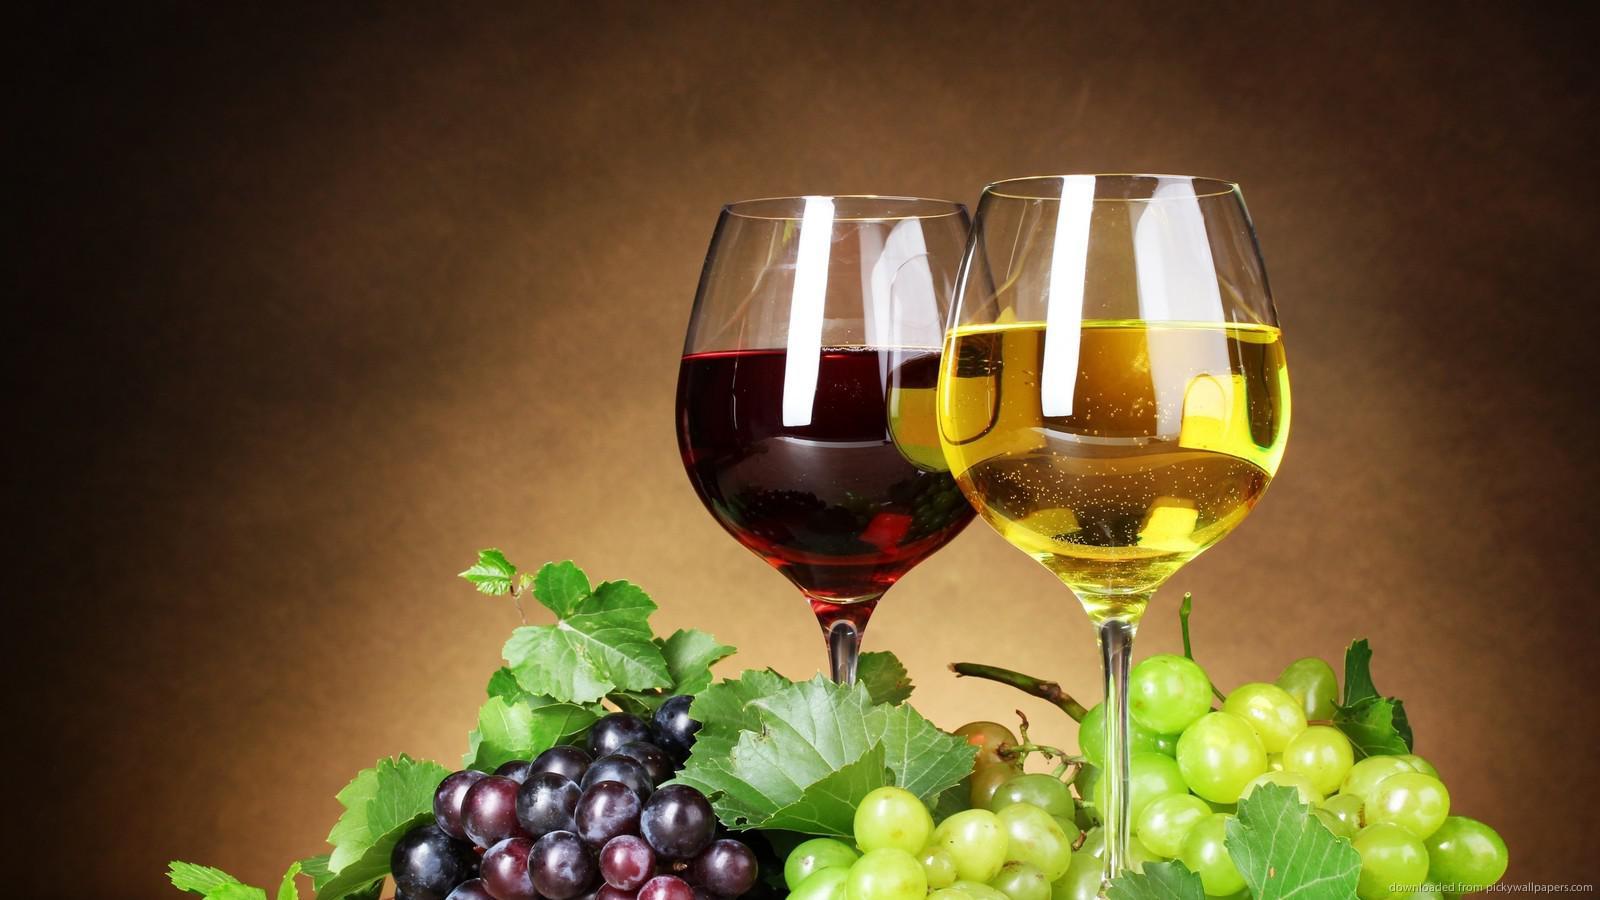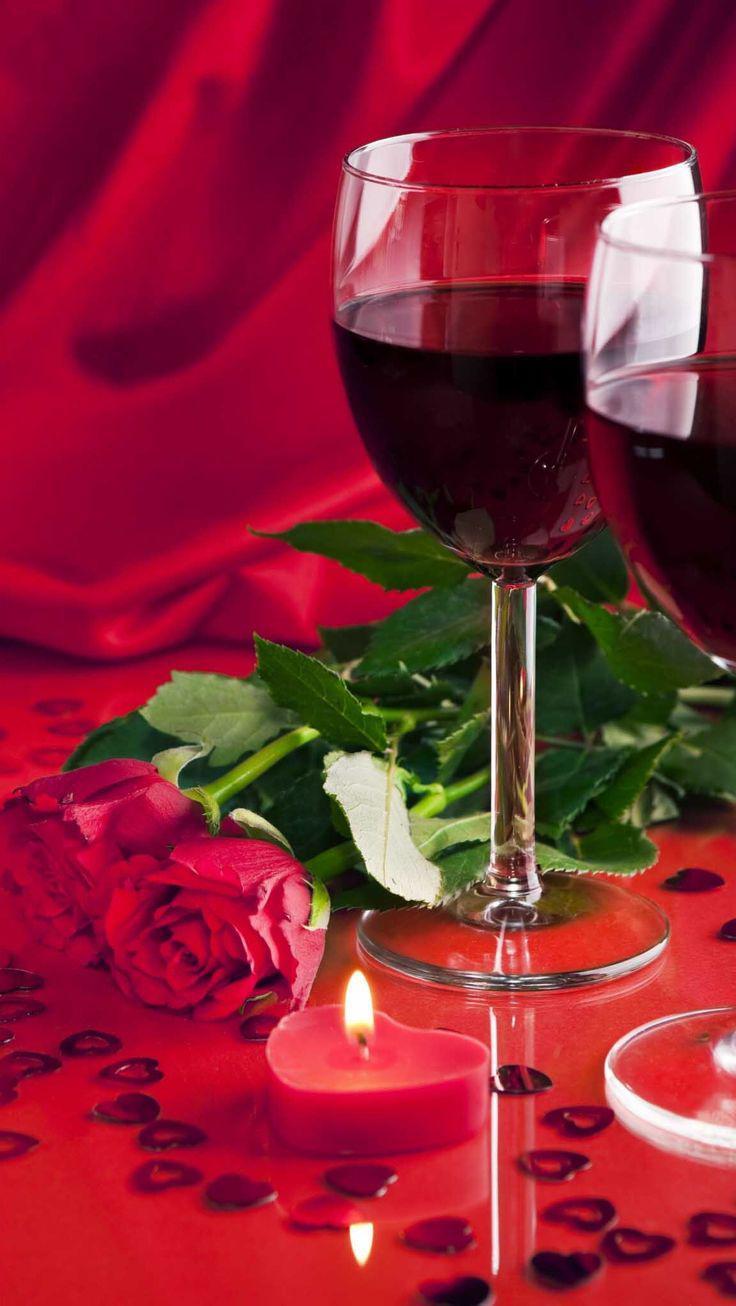The first image is the image on the left, the second image is the image on the right. For the images displayed, is the sentence "The wine glasses are near wicker picnic baskets." factually correct? Answer yes or no. No. 